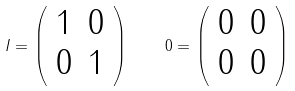<formula> <loc_0><loc_0><loc_500><loc_500>I = \left ( \begin{array} { l l } 1 & 0 \\ 0 & 1 \end{array} \right ) \quad 0 = \left ( \begin{array} { l l } 0 & 0 \\ 0 & 0 \end{array} \right )</formula> 